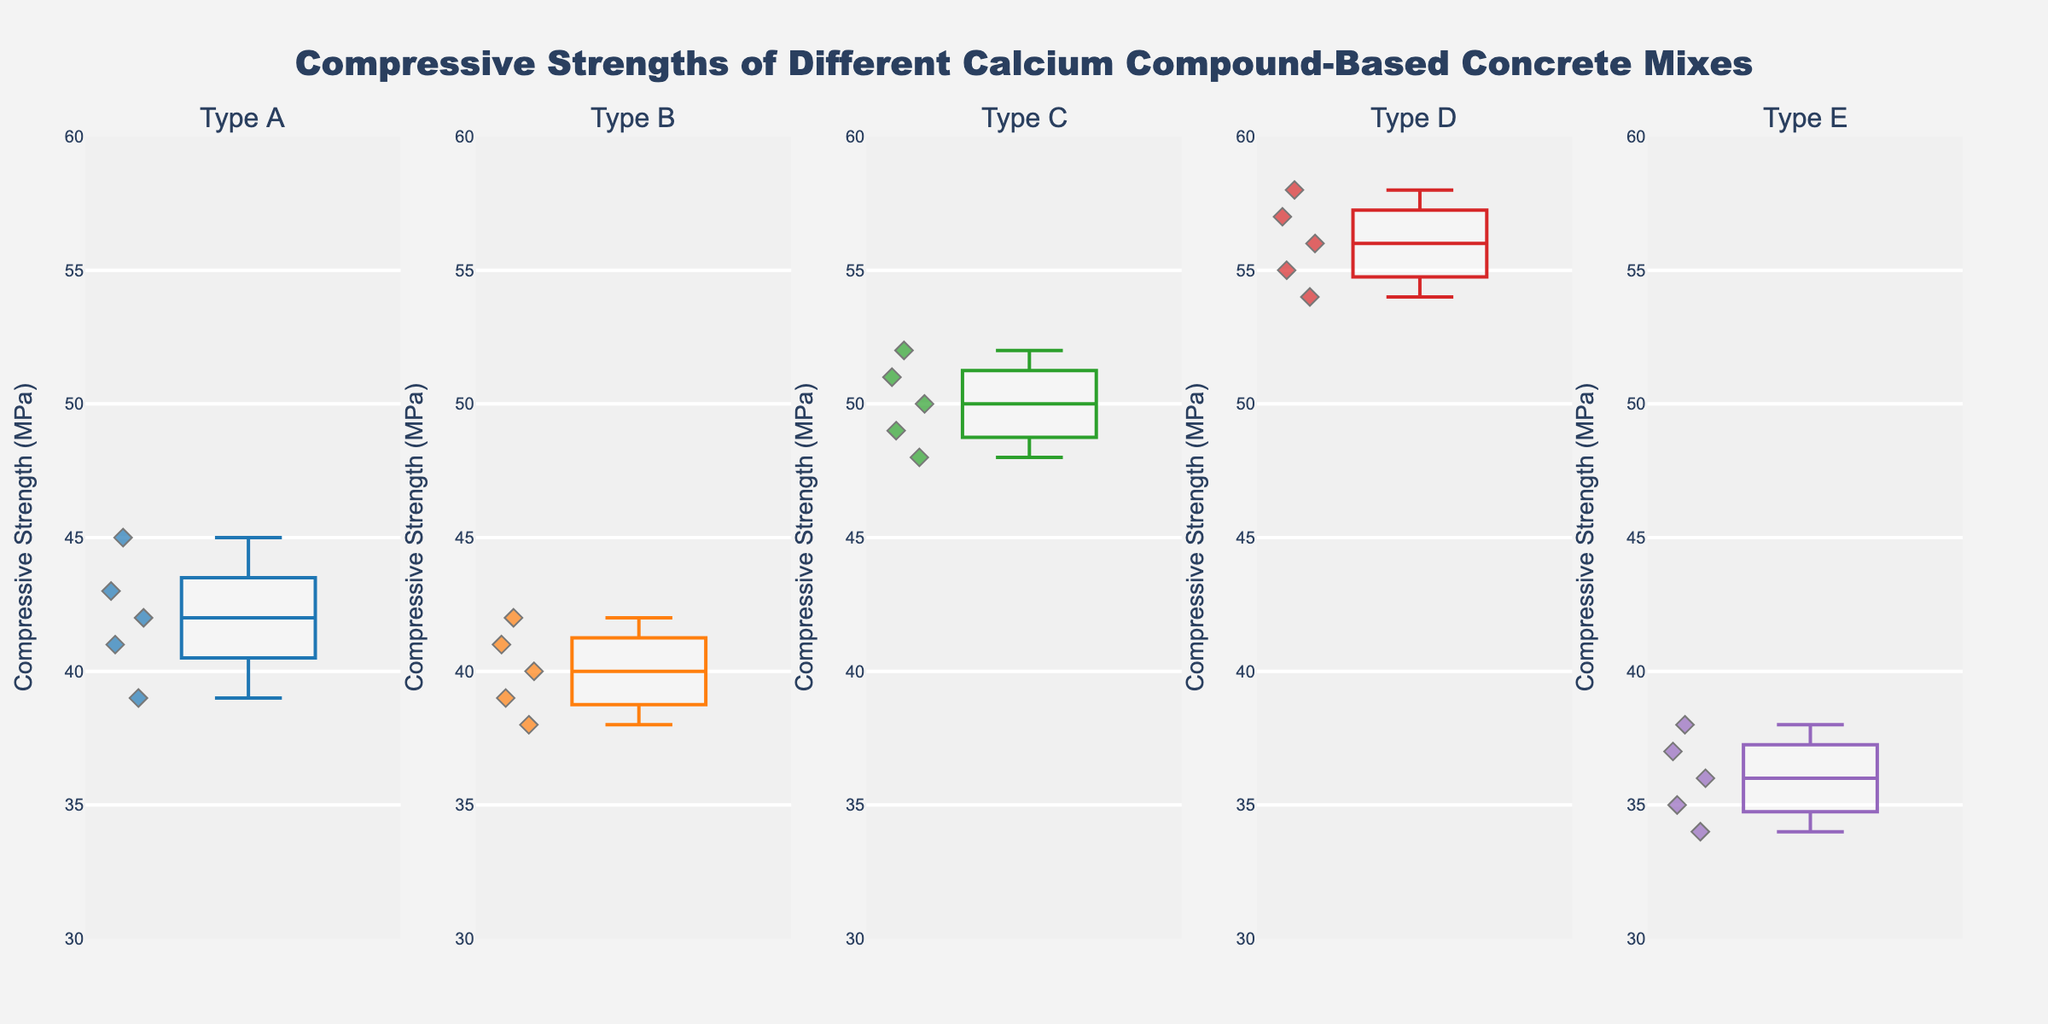What is the title of the figure? The title of the figure is located at the top of the plot. The text "Compressive Strengths of Different Calcium Compound-Based Concrete Mixes" is centered and positioned at the top.
Answer: Compressive Strengths of Different Calcium Compound-Based Concrete Mixes What is the y-axis label in the figure? The y-axis label is found on the vertical axis of the figure. It reads "Compressive Strength (MPa)."
Answer: Compressive Strength (MPa) Which Concrete Type has the highest median compressive strength? By referring to the median line in each box plot, Concrete Type D (Calcium Aluminate) has the highest median compressive strength, visually appearing at a higher level compared to others.
Answer: Type D How many data points are represented in Concrete Type B's box plot? Each box plot displays individual data points as diamonds. Counting these points for Concrete Type B (Calcium Sulfate) shows there are 5 data points.
Answer: 5 What is the range of compressive strengths for Concrete Type C? The range of a box plot can be seen from the minimum (bottom whisker) to the maximum (top whisker). For Concrete Type C (Calcium Silicate), the range is from 48 MPa to 52 MPa.
Answer: 48 MPa to 52 MPa Which Concrete Type has the lowest maximum compressive strength? The maximum compressive strength for each type is the highest point of the top whisker. Concrete Type E (Calcium Hydroxide) has the lowest maximum compressive strength of 38 MPa.
Answer: Type E How does the spread of compressive strengths in Type A compare to Type D? Comparing the spread, or interquartile ranges (IQR), Type A (Calcium Carbonate) has a smaller spread between 39 MPa and 45 MPa, whereas Type D (Calcium Aluminate) has a larger spread between 54 MPa and 58 MPa.
Answer: Type A has a smaller spread Which Concrete Type shows the most consistent compressive strength values? Consistency is indicated by the size of the IQR and the whiskers. The narrowest box and whiskers represent the most consistent values. Concrete Type C (Calcium Silicate) shows the most consistency, with strengths closely packed between 48 MPa and 52 MPa.
Answer: Type C 